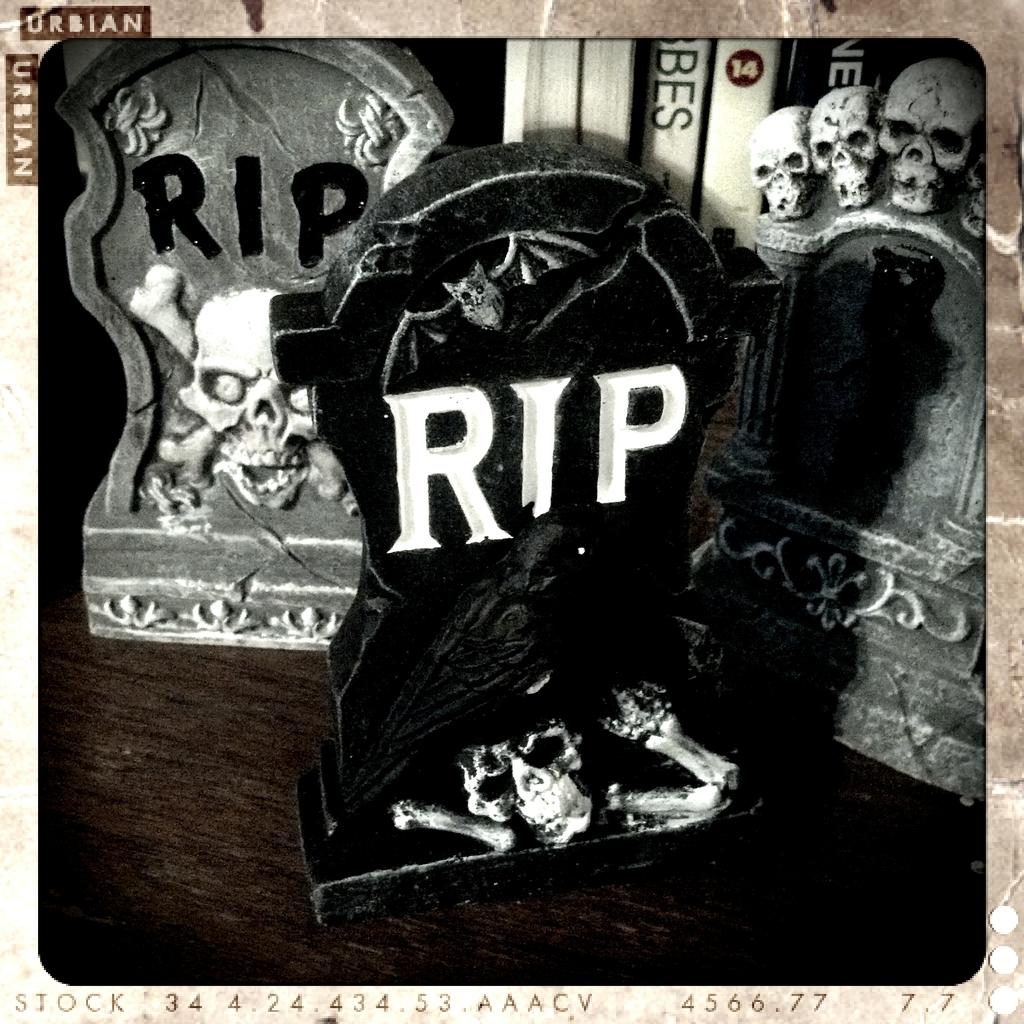What letters are on the tombstone?
Provide a succinct answer. Rip. 